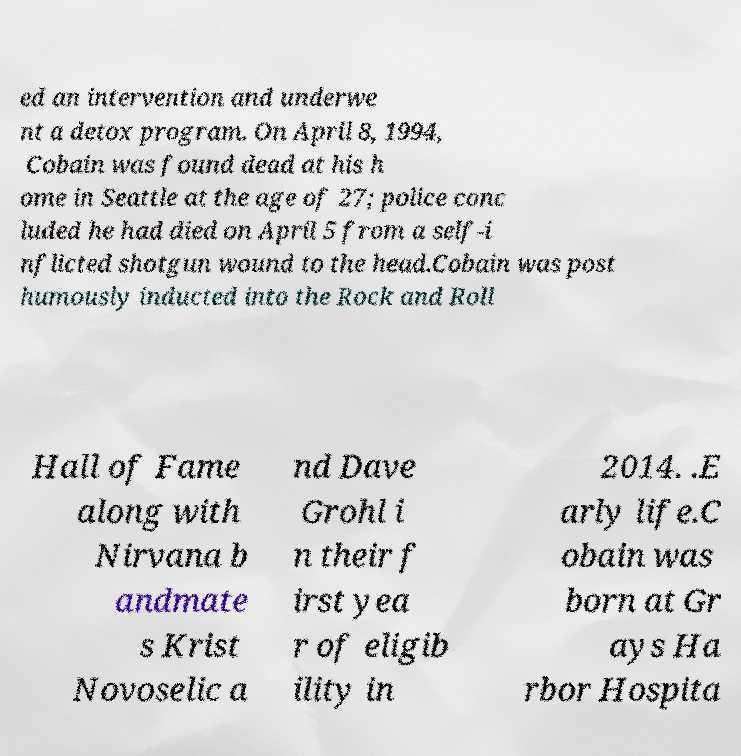Please read and relay the text visible in this image. What does it say? ed an intervention and underwe nt a detox program. On April 8, 1994, Cobain was found dead at his h ome in Seattle at the age of 27; police conc luded he had died on April 5 from a self-i nflicted shotgun wound to the head.Cobain was post humously inducted into the Rock and Roll Hall of Fame along with Nirvana b andmate s Krist Novoselic a nd Dave Grohl i n their f irst yea r of eligib ility in 2014. .E arly life.C obain was born at Gr ays Ha rbor Hospita 